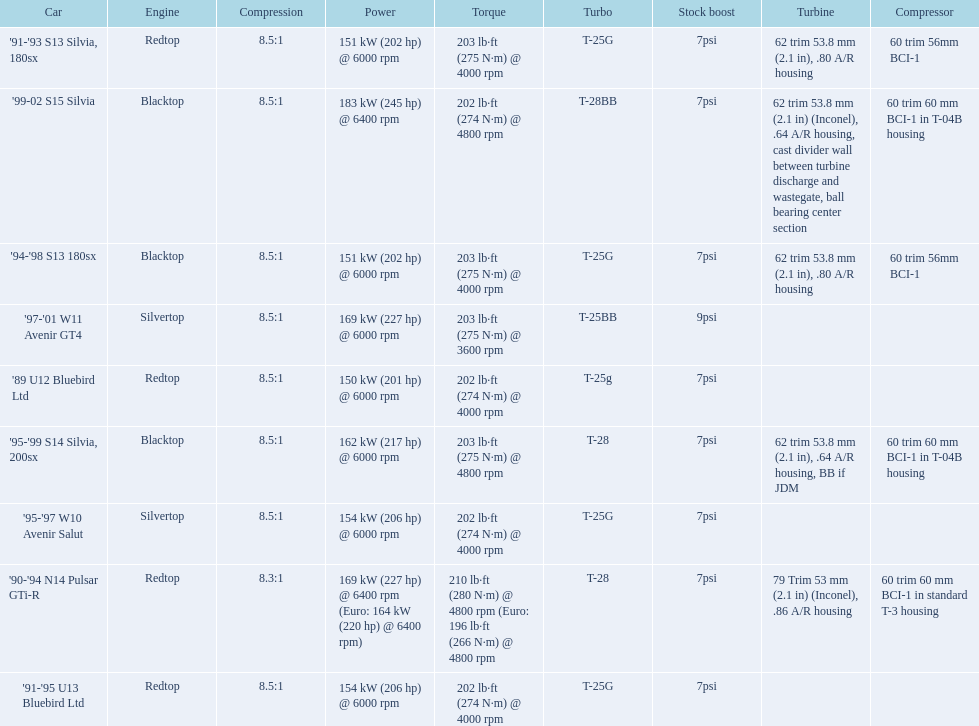What are all of the cars? '89 U12 Bluebird Ltd, '91-'95 U13 Bluebird Ltd, '95-'97 W10 Avenir Salut, '97-'01 W11 Avenir GT4, '90-'94 N14 Pulsar GTi-R, '91-'93 S13 Silvia, 180sx, '94-'98 S13 180sx, '95-'99 S14 Silvia, 200sx, '99-02 S15 Silvia. What is their rated power? 150 kW (201 hp) @ 6000 rpm, 154 kW (206 hp) @ 6000 rpm, 154 kW (206 hp) @ 6000 rpm, 169 kW (227 hp) @ 6000 rpm, 169 kW (227 hp) @ 6400 rpm (Euro: 164 kW (220 hp) @ 6400 rpm), 151 kW (202 hp) @ 6000 rpm, 151 kW (202 hp) @ 6000 rpm, 162 kW (217 hp) @ 6000 rpm, 183 kW (245 hp) @ 6400 rpm. Which car has the most power? '99-02 S15 Silvia. 